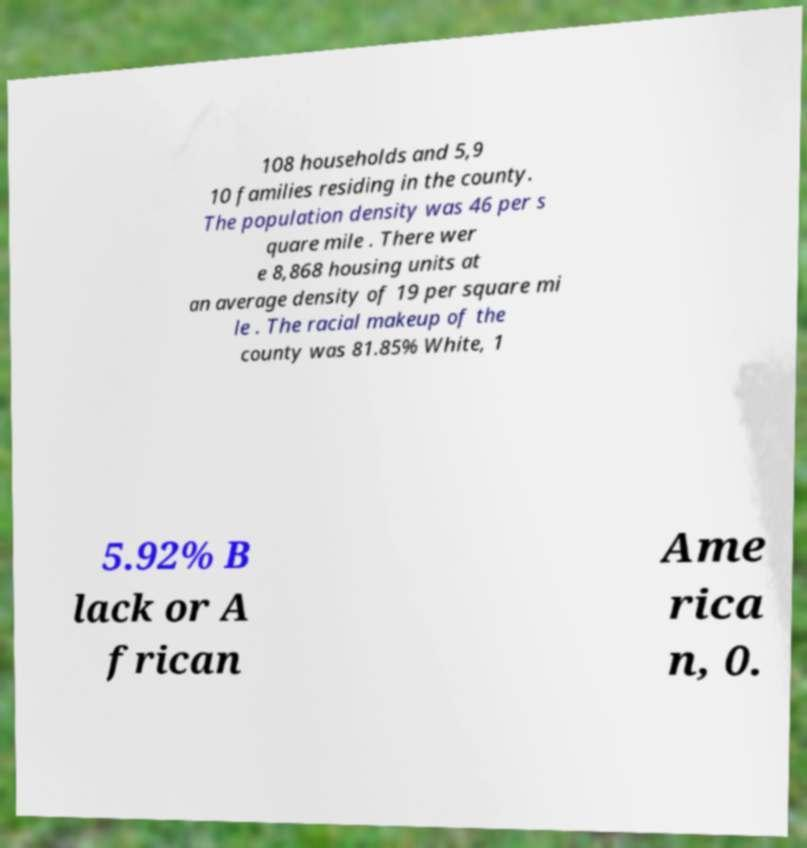Please identify and transcribe the text found in this image. 108 households and 5,9 10 families residing in the county. The population density was 46 per s quare mile . There wer e 8,868 housing units at an average density of 19 per square mi le . The racial makeup of the county was 81.85% White, 1 5.92% B lack or A frican Ame rica n, 0. 